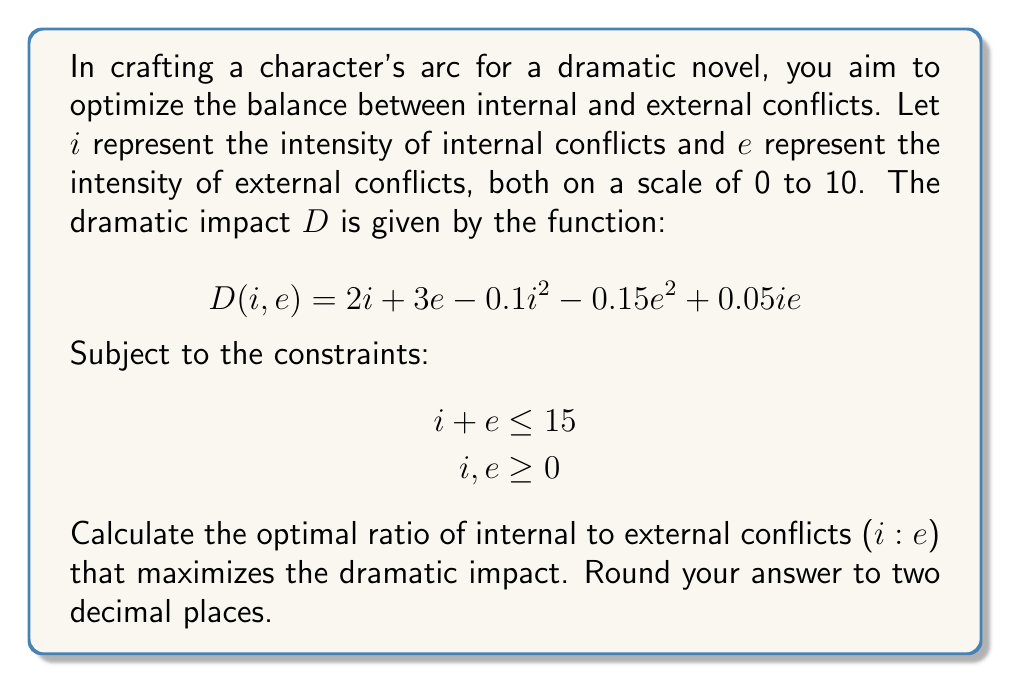Can you answer this question? To solve this optimization problem, we'll use the method of Lagrange multipliers:

1) First, form the Lagrangian function:
   $$L(i, e, \lambda) = 2i + 3e - 0.1i^2 - 0.15e^2 + 0.05ie + \lambda(15 - i - e)$$

2) Take partial derivatives and set them equal to zero:
   $$\frac{\partial L}{\partial i} = 2 - 0.2i + 0.05e - \lambda = 0$$
   $$\frac{\partial L}{\partial e} = 3 - 0.3e + 0.05i - \lambda = 0$$
   $$\frac{\partial L}{\partial \lambda} = 15 - i - e = 0$$

3) From the first two equations:
   $$2 - 0.2i + 0.05e = 3 - 0.3e + 0.05i$$
   $$-0.25i = 1 - 0.35e$$
   $$i = 4 - 1.4e$$

4) Substitute this into the constraint equation:
   $$15 - (4 - 1.4e) - e = 0$$
   $$11 - 0.4e = 0$$
   $$e = 27.5$$

5) But $e$ cannot exceed 10, so we set $e = 10$

6) Substituting back:
   $$i = 4 - 1.4(10) = -10$$

7) Since $i$ cannot be negative, we need to find the optimal solution on the boundary of the constraint.

8) Let's parameterize the constraint line:
   $$i + e = 15$$
   $$i = 15 - e$$

9) Substitute this into the original function:
   $$D(e) = 2(15-e) + 3e - 0.1(15-e)^2 - 0.15e^2 + 0.05(15-e)e$$
   $$= 30 - 2e + 3e - 0.1(225 - 30e + e^2) - 0.15e^2 + 0.75e - 0.05e^2$$
   $$= 30 + e - 22.5 + 3e - 0.1e^2 - 0.15e^2 + 0.75e - 0.05e^2$$
   $$= 7.5 + 4.75e - 0.3e^2$$

10) To find the maximum, differentiate and set to zero:
    $$\frac{dD}{de} = 4.75 - 0.6e = 0$$
    $$e = 7.92$$

11) Therefore, $i = 15 - 7.92 = 7.08$

12) The ratio $i:e$ is $7.08 : 7.92 = 0.89 : 1$
Answer: The optimal ratio of internal to external conflicts is 0.89 : 1. 